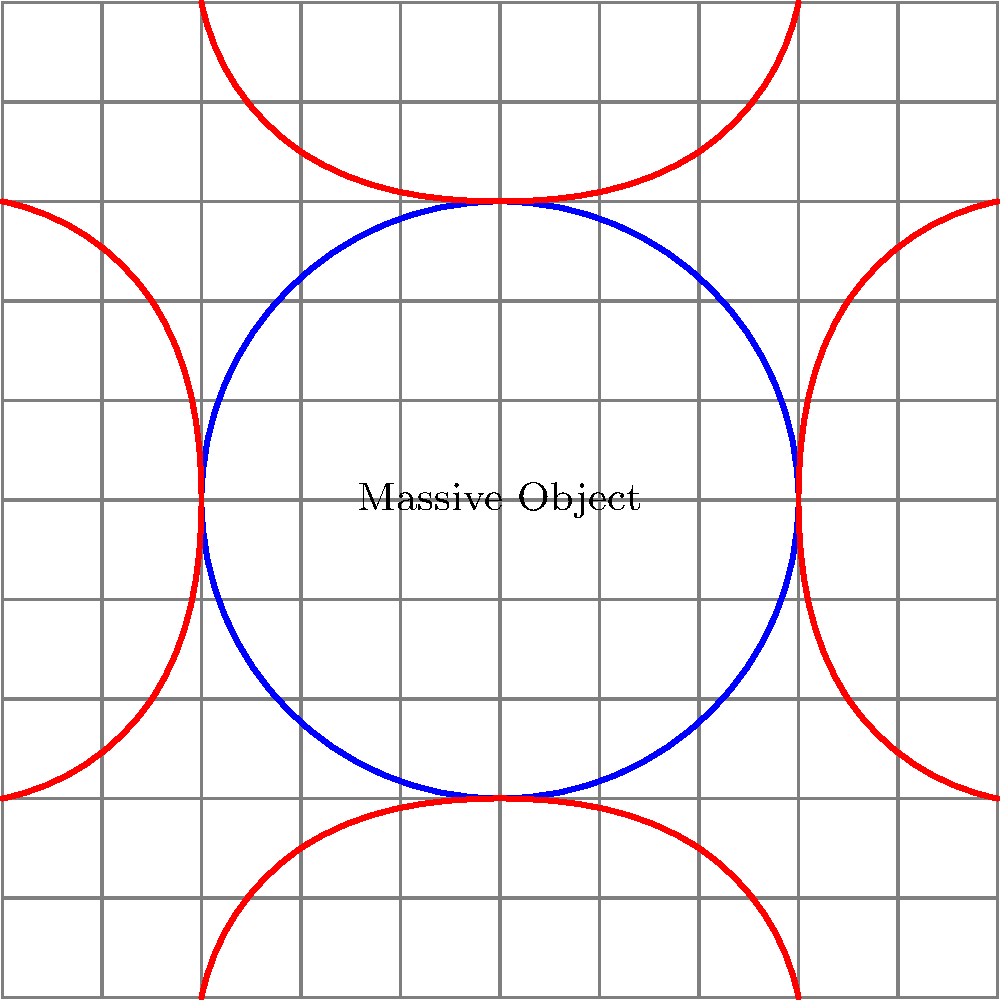In the context of general relativity, the image above represents the curvature of spacetime around a massive object using a 2D grid. If a beam of light were to travel along one of the curved red lines, what would an observer at a distance perceive about the path of this light, and how does this relate to the concept of gravitational lensing? To understand this phenomenon, let's break it down step-by-step:

1. In general relativity, massive objects curve spacetime around them. This is represented in the image by the distortion of the grid lines near the blue circle (massive object).

2. The red curved lines represent the paths that light would follow in this curved spacetime. These are called geodesics - the shortest path between two points in curved spacetime.

3. Light always travels along geodesics. In flat spacetime, these would be straight lines. However, in curved spacetime, they appear bent.

4. An observer far from the massive object would be in a region of relatively flat spacetime. From their perspective, light appears to travel in straight lines.

5. When the observer sees light that has passed near the massive object, they will perceive it as having followed a curved path. This is because the light has actually traveled along a geodesic in curved spacetime, but the observer interprets this in their flat spacetime framework.

6. This bending of light due to the curvature of spacetime is known as gravitational lensing. It can cause distant objects to appear in different positions or even create multiple images of the same object.

7. The degree of bending depends on the mass of the object and how close the light passes to it. This is described by the Einstein radius, given by the equation:

   $$\theta_E = \sqrt{\frac{4GM}{c^2}\frac{D_{LS}}{D_L D_S}}$$

   where $G$ is the gravitational constant, $M$ is the mass of the lensing object, $c$ is the speed of light, and $D_{LS}$, $D_L$, and $D_S$ are the distances between lens-source, observer-lens, and observer-source respectively.

8. Gravitational lensing is a powerful tool in astrophysics, used to study distant galaxies, detect dark matter, and even search for exoplanets.
Answer: The observer would perceive the light as following a curved path, demonstrating gravitational lensing. 